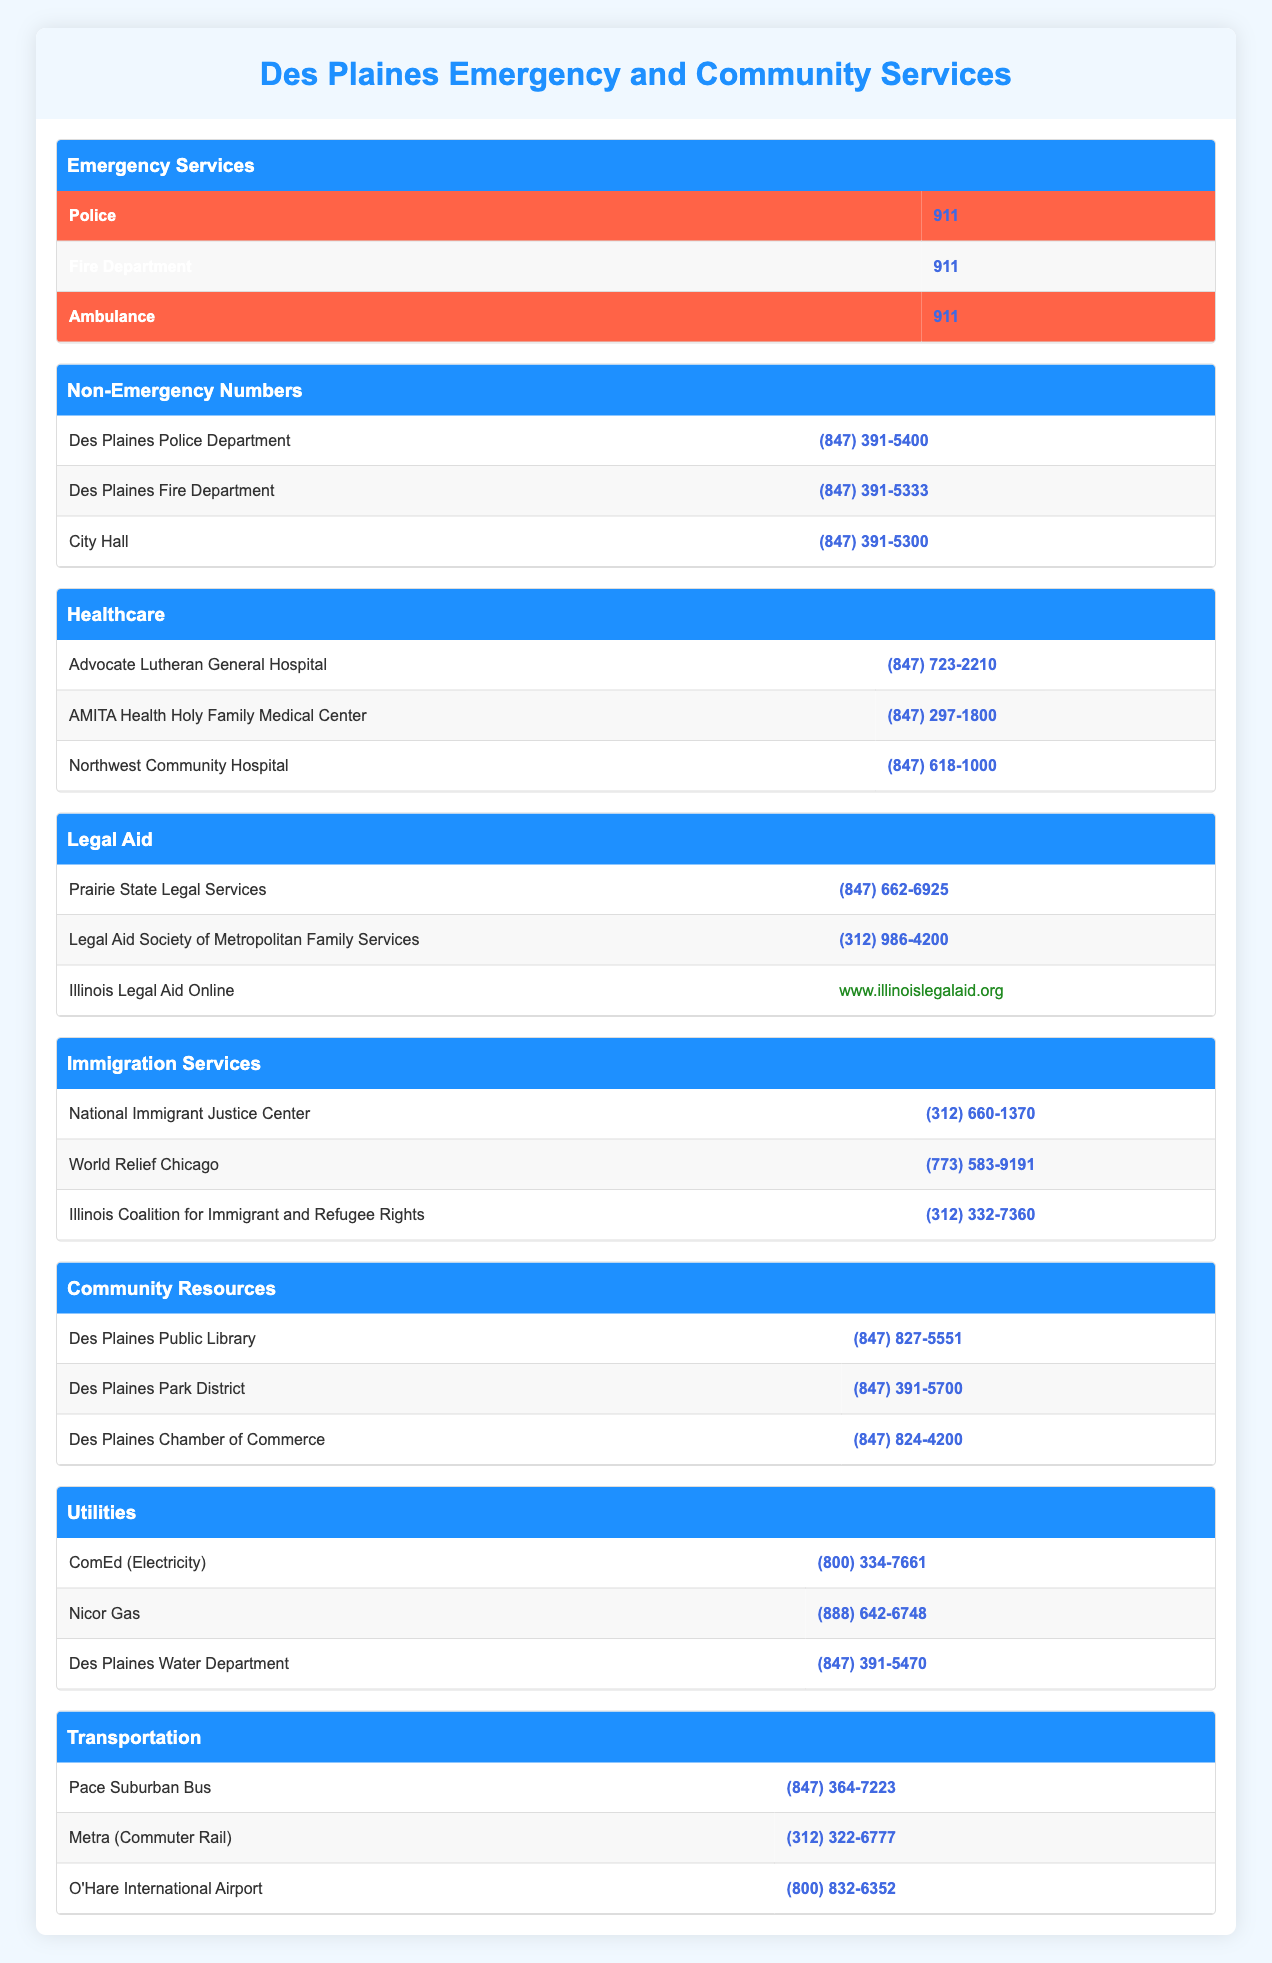What is the emergency number for the police in Des Plaines? The emergency number for the police is listed in the Emergency Services section of the table. It states that the Police can be reached at 911.
Answer: 911 What is the contact number for the Des Plaines Fire Department? The Des Plaines Fire Department's number is found under Non-Emergency Numbers in the table. It states the number is (847) 391-5333.
Answer: (847) 391-5333 Is Advocate Lutheran General Hospital in Des Plaines? Advocate Lutheran General Hospital is mentioned in the Healthcare section of the table. Since it's listed with a contact number but not specifically stated to be in Des Plaines, the answer is ambiguous. However, it is a well-known hospital in the area.
Answer: Yes How many healthcare facilities are listed in the table? The table lists three healthcare facilities: Advocate Lutheran General Hospital, AMITA Health Holy Family Medical Center, and Northwest Community Hospital. Therefore, we count them to find a total of three.
Answer: 3 Which service has the highest priority number in the table? The priority number 911 is listed multiple times for different emergency services: Police, Fire Department, and Ambulance. To determine the highest priority number, we see that all these services share the same number, which signifies emergencies.
Answer: 911 What is the average number of digits in the phone numbers listed for Legal Aid services? There are three phone numbers listed in the Legal Aid section: (847) 662-6925, (312) 986-4200, and a website. We count the digits in the phone numbers only, which total 10 digits each. Therefore, the sum is 10 + 10 + 10 = 30, and the average is 30/3 = 10.
Answer: 10 Are there more non-emergency numbers for healthcare or for legal aid services? The table shows there are zero non-emergency numbers for healthcare, as all healthcare numbers are emergency-related (911). Legal aid, however, has three listed services. Therefore, comparing both groups shows legal aid has more non-emergency numbers: 0 for healthcare and 3 for legal aid.
Answer: Legal aid What is the contact number for the Des Plaines Water Department? The contact number for the Des Plaines Water Department can be found in the Utilities section of the table. The table states the number is (847) 391-5470.
Answer: (847) 391-5470 How many transportation services are listed, and what is the number for Metra? The table provides three transportation services: Pace Suburban Bus, Metra, and O'Hare International Airport. To answer the question, we count the services (3) and also refer to the table for Metra's contact number, which is (312) 322-6777. Therefore, the results are 3 services and the number.
Answer: 3, (312) 322-6777 